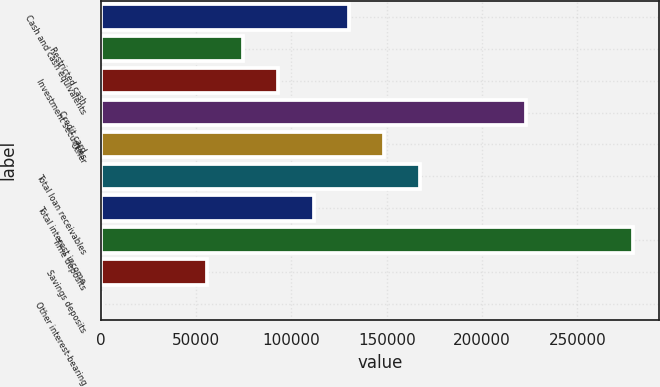Convert chart. <chart><loc_0><loc_0><loc_500><loc_500><bar_chart><fcel>Cash and cash equivalents<fcel>Restricted cash<fcel>Investment securities<fcel>Credit card<fcel>Other<fcel>Total loan receivables<fcel>Total interest income<fcel>Time deposits<fcel>Savings deposits<fcel>Other interest-bearing<nl><fcel>130223<fcel>74443.4<fcel>93036.5<fcel>223188<fcel>148816<fcel>167409<fcel>111630<fcel>278968<fcel>55850.3<fcel>71<nl></chart> 